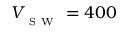Convert formula to latex. <formula><loc_0><loc_0><loc_500><loc_500>V _ { _ { S W } } = 4 0 0</formula> 